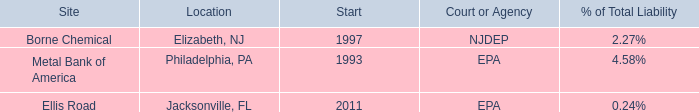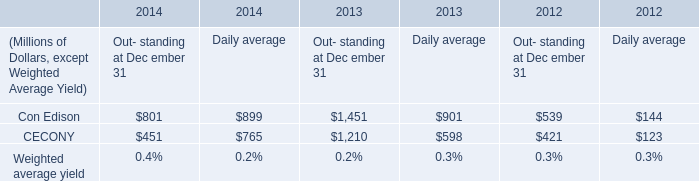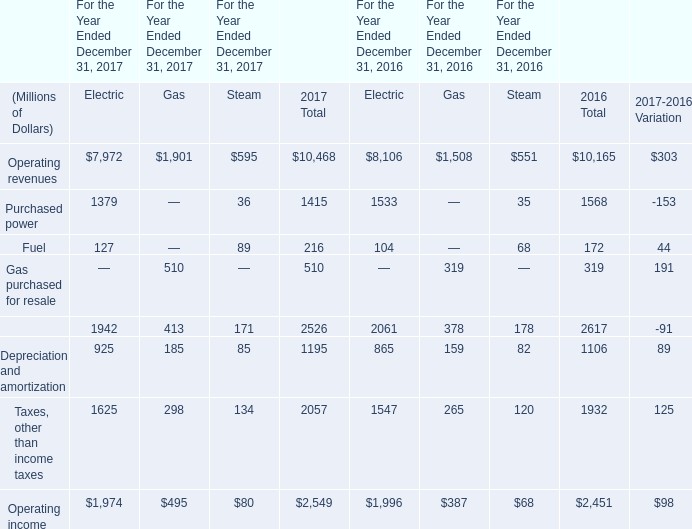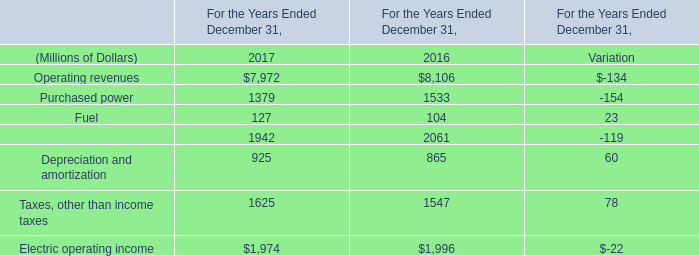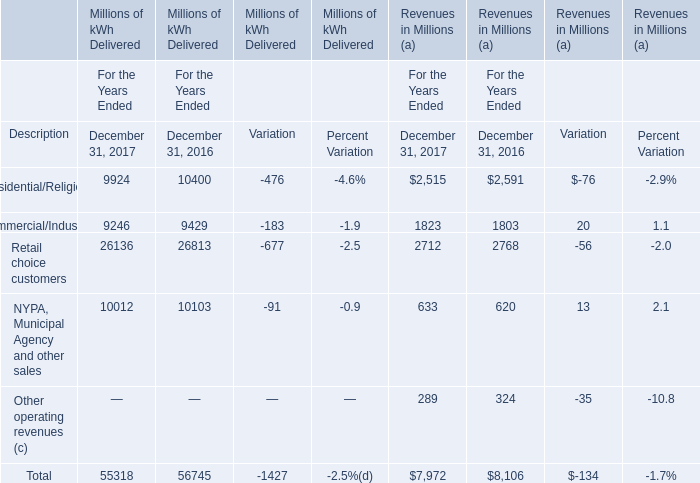what is the highest total amount of Residential/Religious (b)? (in milllion) 
Answer: 10400. 